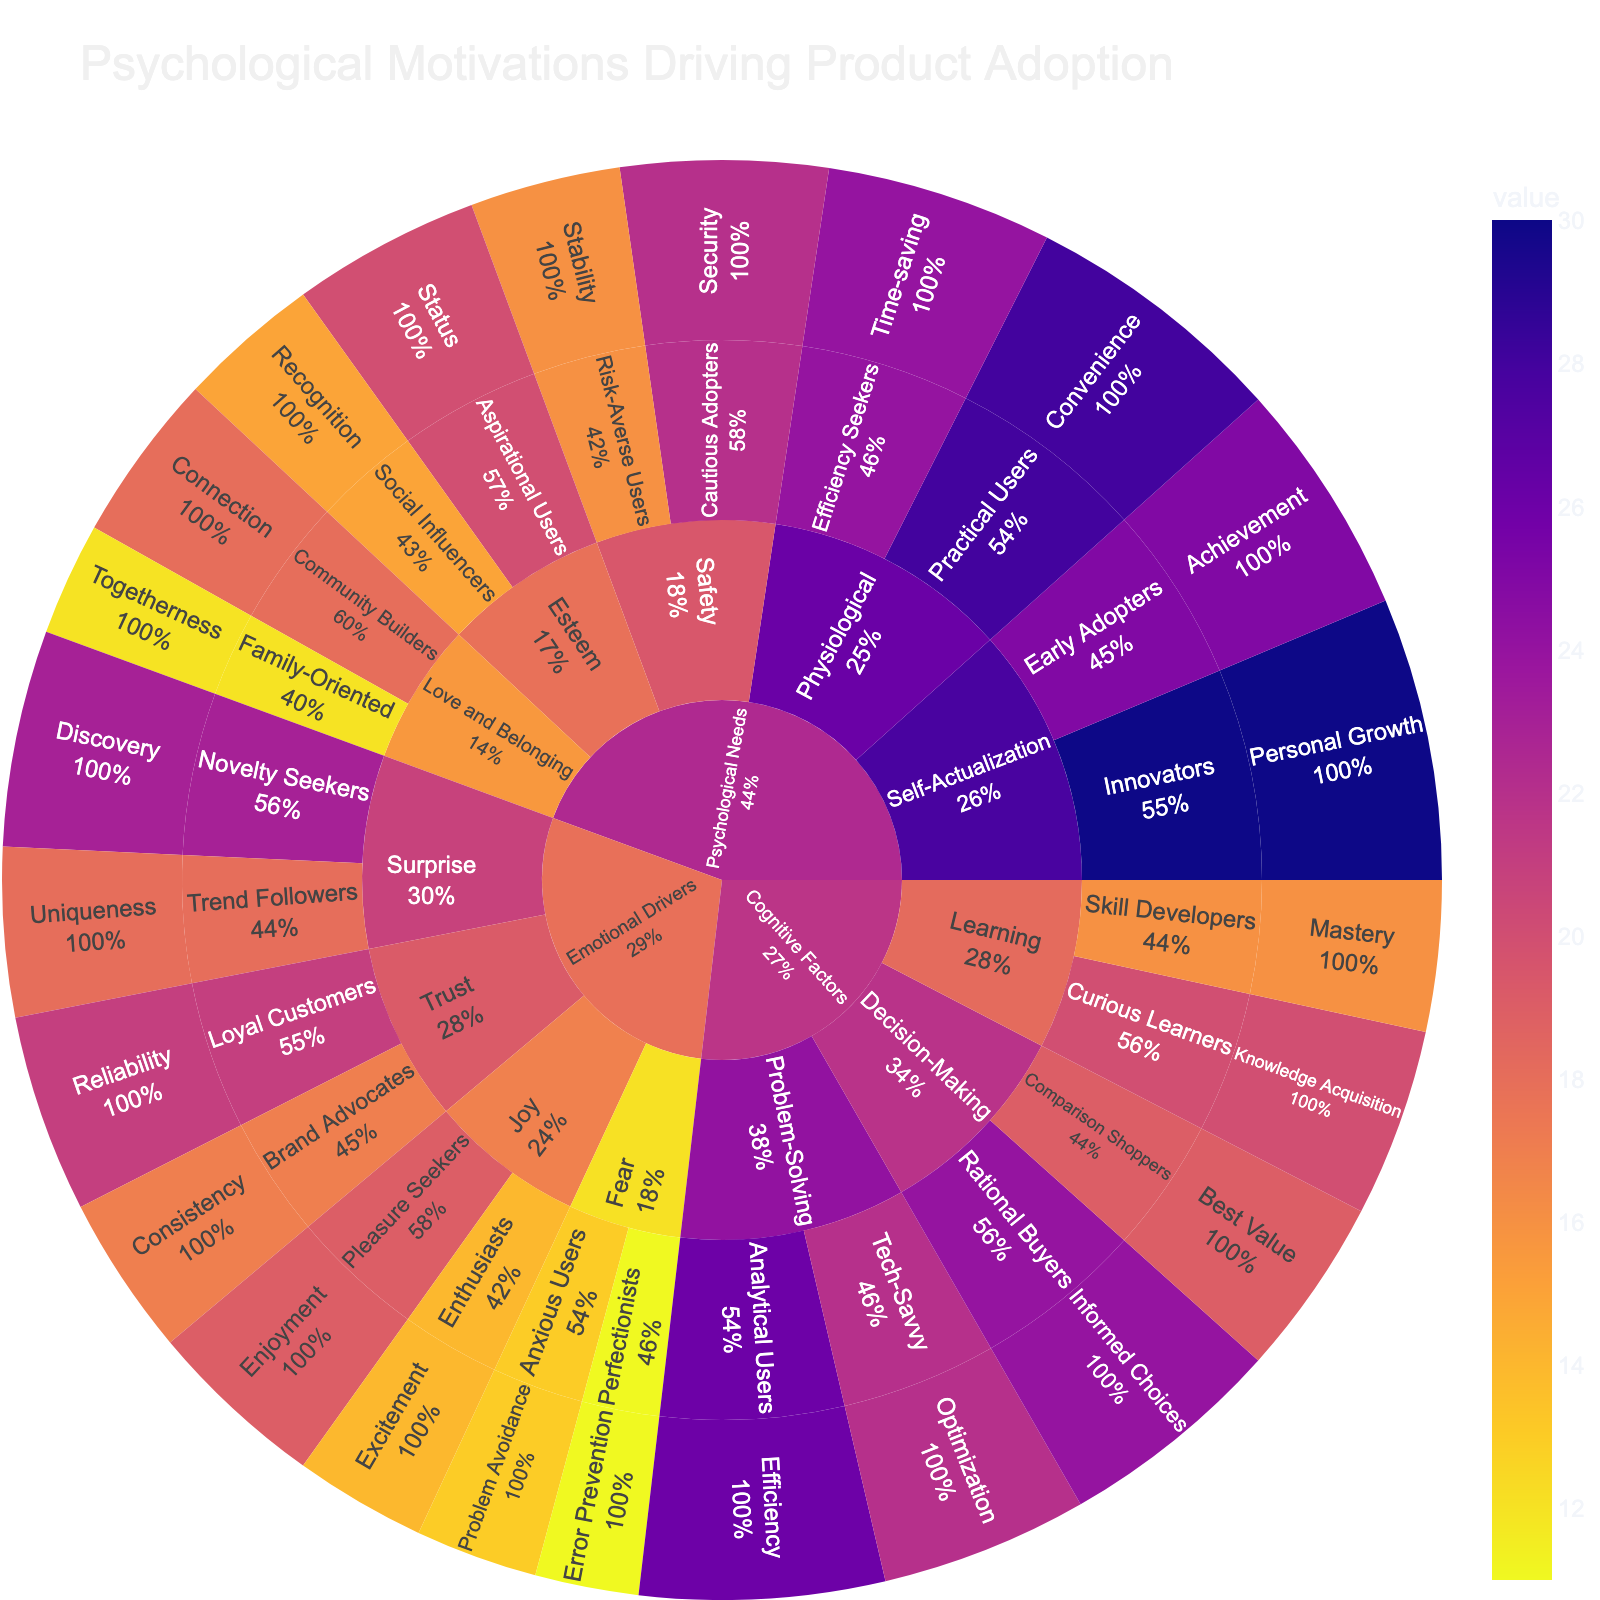What is the value associated with the 'Convenience' motivation for Practical Users? Locate the 'Physiological' subcategory under 'Psychological Needs', then identify the 'Practical Users' persona and the 'Convenience' motivation. The value is indicated next to 'Convenience'.
Answer: 28 What is the combined value of motivations under 'Self-Actualization'? Locate the 'Self-Actualization' subcategory, sum the values of 'Personal Growth' (30) and 'Achievement' (25).
Answer: 55 Which persona has the highest value in the 'Cognitive Factors' category? In the 'Cognitive Factors' category, look at the personas across subcategories. The maximum value is 26 for 'Analytical Users' under 'Problem-Solving'.
Answer: Analytical Users What is the difference in value between 'Problem Avoidance' for 'Anxious Users' and 'Error Prevention' for 'Perfectionists'? Identify the values for 'Problem Avoidance' (13) and 'Error Prevention' (11) under the 'Fear' subcategory in 'Emotional Drivers'. Calculate the difference, 13 - 11.
Answer: 2 What percentage of parent does 'Mastery' for Skill Developers hold in the 'Learning' subcategory? Locate 'Skill Developers' in the 'Learning' subcategory under 'Cognitive Factors'. The percentage can be found in the sunburst plot's details when hovering over 'Mastery'.
Answer: The plot details will show this; examine the exact value there Which subcategory within 'Emotional Drivers' contains the highest total value of motivations? Add values within each subcategory of 'Emotional Drivers': Joy (19+14), Trust (21+17), Fear (13+11), Surprise (23+18). The highest sum is 41 for Trust.
Answer: Trust How does the value of 'Stability' for Risk-Averse Users compare to 'Security' for Cautious Adopters in 'Safety'? In 'Safety', compare 'Stability' (16) for Risk-Averse Users and 'Security' (22) for Cautious Adopters. 16 < 22, so 'Stability' is lower.
Answer: Stability is lower What is the average value of motivations in the 'Love and Belonging' subcategory? Add the values of 'Connection' (18) and 'Togetherness' (12) in 'Love and Belonging', then divide by 2. (18+12)/2 = 15
Answer: 15 How many user personas are there in the 'Decision-Making' subcategory? Count the distinct personas listed under 'Decision-Making' in the 'Cognitive Factors' category. They are 'Rational Buyers' and 'Comparison Shoppers'.
Answer: 2 What is the total value of all motivations under 'Psychological Needs'? Add values from all subcategories under 'Psychological Needs': 30, 25, 20, 15, 18, 12, 22, 16, 28, 24. Sum these values.
Answer: 210 